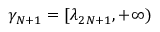<formula> <loc_0><loc_0><loc_500><loc_500>\gamma _ { N + 1 } = [ \lambda _ { 2 N + 1 } , + \infty )</formula> 